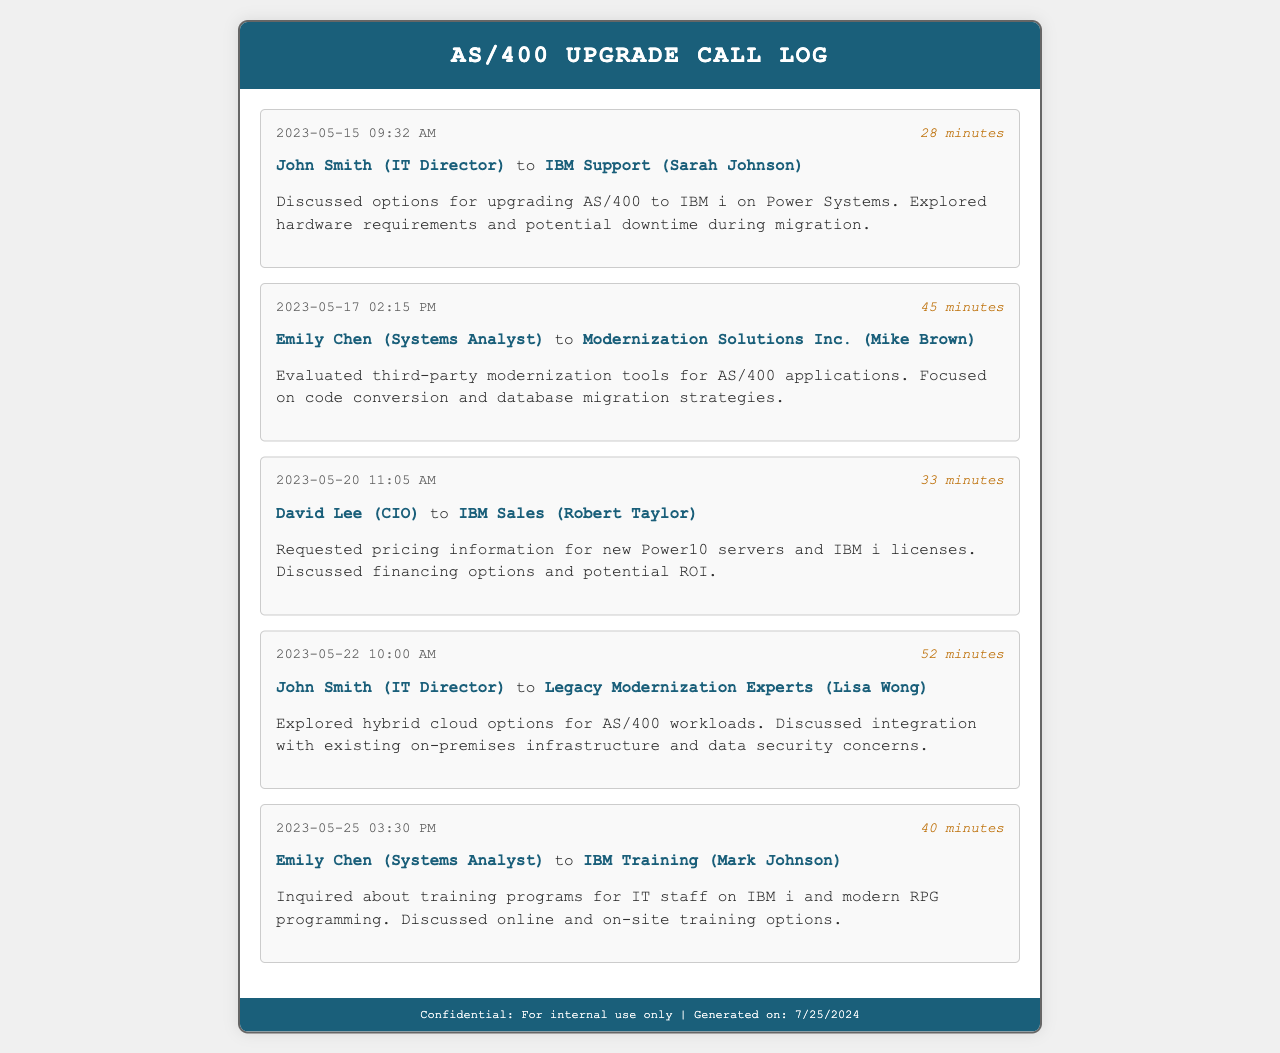What was the date of the first call? The first call occurred on May 15, 2023.
Answer: May 15, 2023 Who was the recipient for the call on May 20, 2023? The recipient of the call on May 20, 2023 was IBM Sales (Robert Taylor).
Answer: IBM Sales (Robert Taylor) How long did the call on May 22, 2023, last? The call on May 22, 2023 lasted for 52 minutes.
Answer: 52 minutes What topic was discussed during the call with Legacy Modernization Experts? The call with Legacy Modernization Experts discussed hybrid cloud options for AS/400 workloads.
Answer: Hybrid cloud options for AS/400 workloads Who is the caller in the last recorded call? The caller in the last recorded call is Emily Chen (Systems Analyst).
Answer: Emily Chen (Systems Analyst) How many calls were made to IBM Support? There was 1 call made to IBM Support.
Answer: 1 What was the primary concern discussed during the call with Modernization Solutions Inc.? The primary concern was focused on code conversion and database migration strategies.
Answer: Code conversion and database migration strategies What is the total duration of calls made by John Smith? The total duration of calls made by John Smith is 80 minutes (28 + 52).
Answer: 80 minutes What training options were discussed in the call with IBM Training? The training options discussed included online and on-site training options.
Answer: Online and on-site training options 